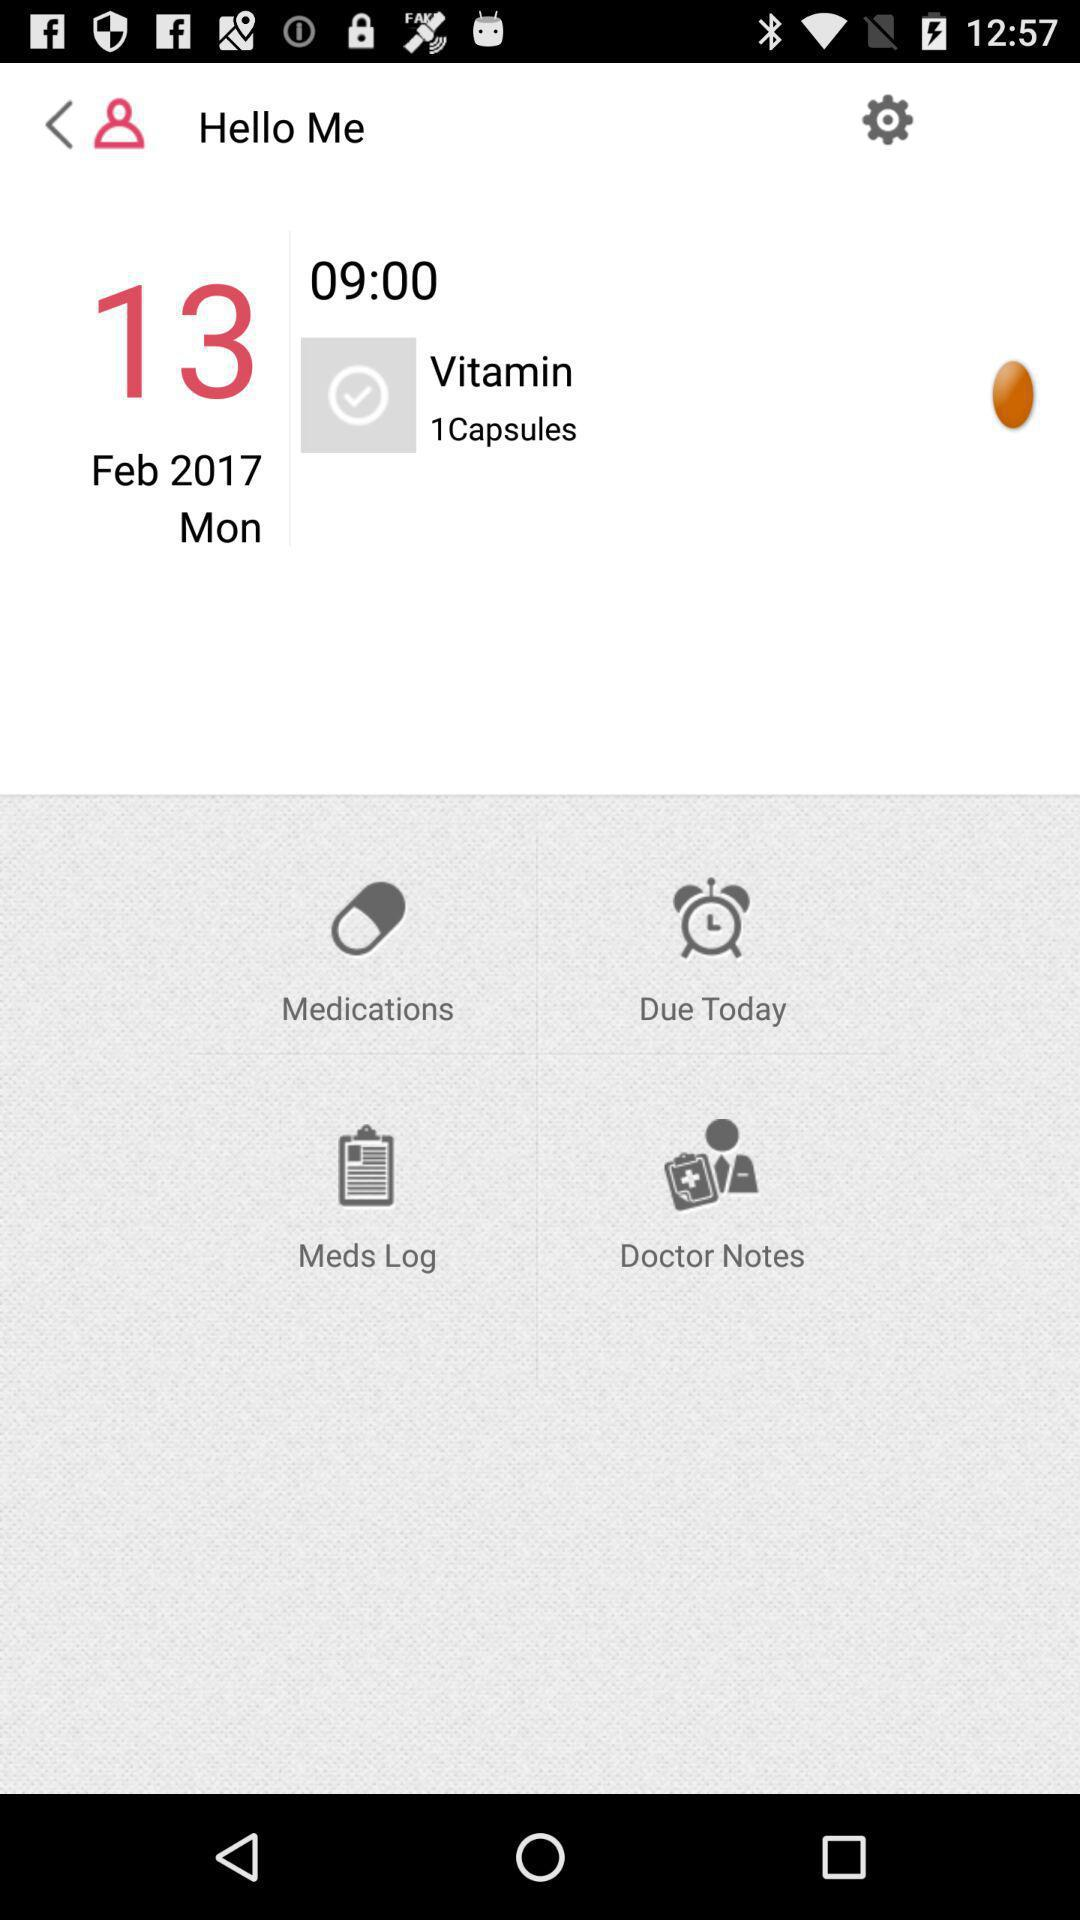What is the time of the next medication?
Answer the question using a single word or phrase. 09:00 